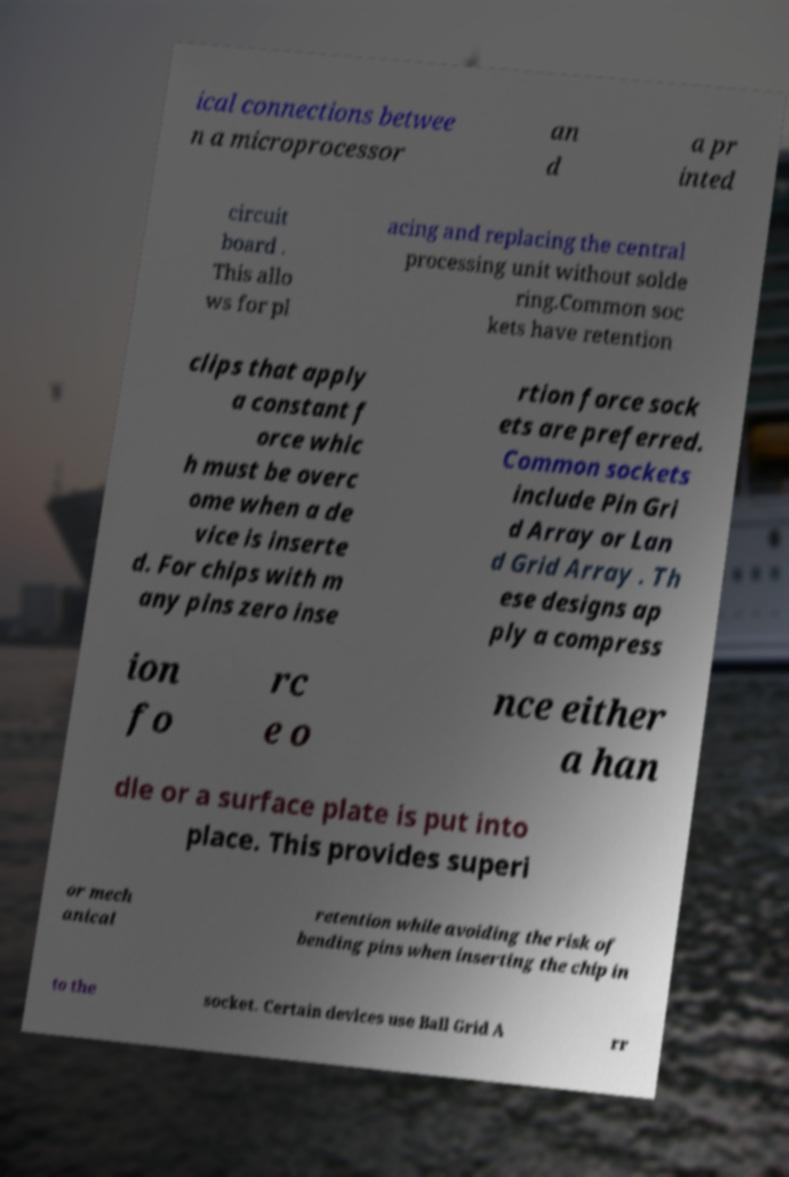Could you extract and type out the text from this image? ical connections betwee n a microprocessor an d a pr inted circuit board . This allo ws for pl acing and replacing the central processing unit without solde ring.Common soc kets have retention clips that apply a constant f orce whic h must be overc ome when a de vice is inserte d. For chips with m any pins zero inse rtion force sock ets are preferred. Common sockets include Pin Gri d Array or Lan d Grid Array . Th ese designs ap ply a compress ion fo rc e o nce either a han dle or a surface plate is put into place. This provides superi or mech anical retention while avoiding the risk of bending pins when inserting the chip in to the socket. Certain devices use Ball Grid A rr 